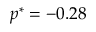<formula> <loc_0><loc_0><loc_500><loc_500>p ^ { * } = - 0 . 2 8</formula> 